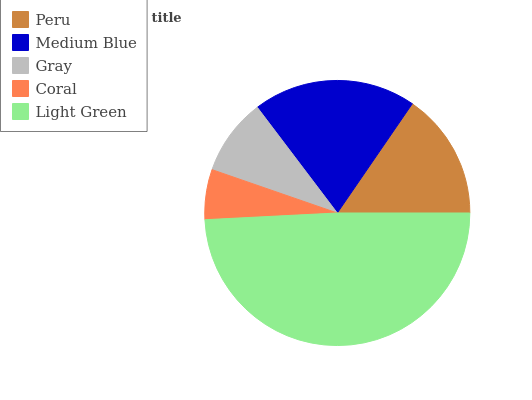Is Coral the minimum?
Answer yes or no. Yes. Is Light Green the maximum?
Answer yes or no. Yes. Is Medium Blue the minimum?
Answer yes or no. No. Is Medium Blue the maximum?
Answer yes or no. No. Is Medium Blue greater than Peru?
Answer yes or no. Yes. Is Peru less than Medium Blue?
Answer yes or no. Yes. Is Peru greater than Medium Blue?
Answer yes or no. No. Is Medium Blue less than Peru?
Answer yes or no. No. Is Peru the high median?
Answer yes or no. Yes. Is Peru the low median?
Answer yes or no. Yes. Is Coral the high median?
Answer yes or no. No. Is Light Green the low median?
Answer yes or no. No. 